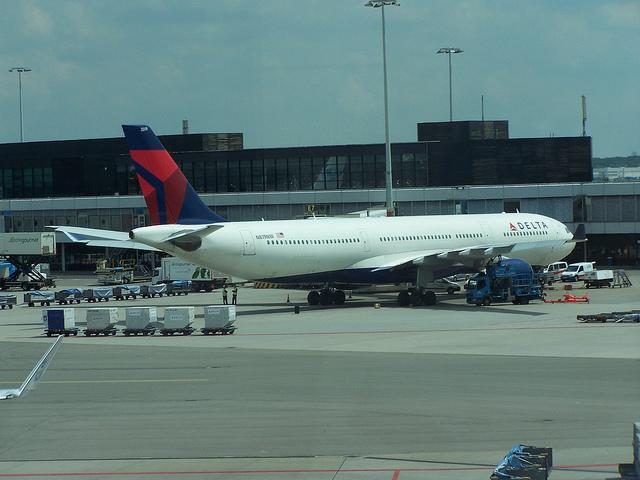Which country does this aircraft brand originate from? usa 